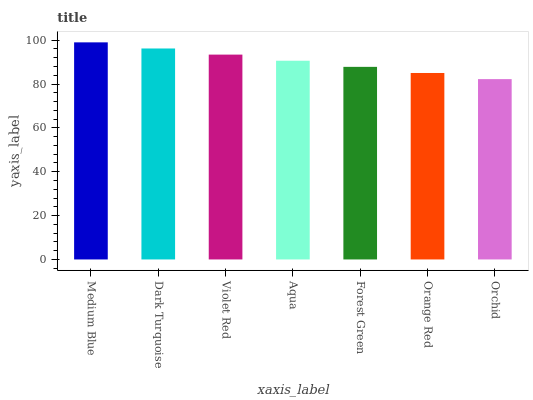Is Orchid the minimum?
Answer yes or no. Yes. Is Medium Blue the maximum?
Answer yes or no. Yes. Is Dark Turquoise the minimum?
Answer yes or no. No. Is Dark Turquoise the maximum?
Answer yes or no. No. Is Medium Blue greater than Dark Turquoise?
Answer yes or no. Yes. Is Dark Turquoise less than Medium Blue?
Answer yes or no. Yes. Is Dark Turquoise greater than Medium Blue?
Answer yes or no. No. Is Medium Blue less than Dark Turquoise?
Answer yes or no. No. Is Aqua the high median?
Answer yes or no. Yes. Is Aqua the low median?
Answer yes or no. Yes. Is Violet Red the high median?
Answer yes or no. No. Is Dark Turquoise the low median?
Answer yes or no. No. 